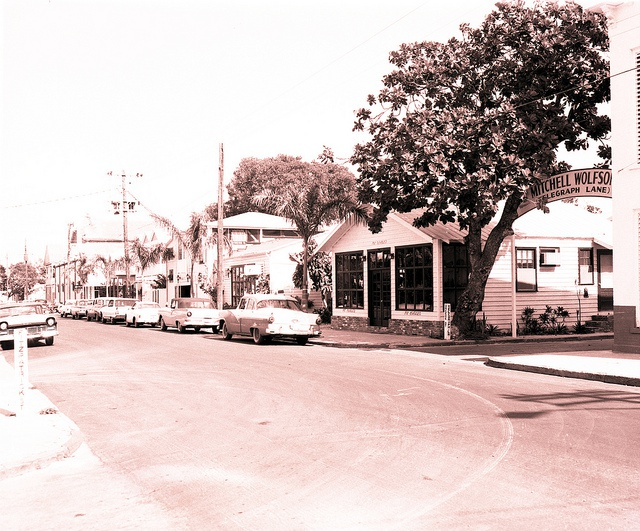Describe the objects in this image and their specific colors. I can see car in white, gray, lightpink, and black tones, car in white, lightpink, black, and gray tones, car in white, lightpink, black, and gray tones, car in white, black, lightpink, and gray tones, and car in white, lightpink, gray, and black tones in this image. 